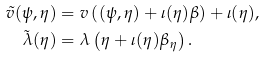Convert formula to latex. <formula><loc_0><loc_0><loc_500><loc_500>\tilde { v } ( \psi , \eta ) & = v \left ( ( \psi , \eta ) + \iota ( \eta ) \beta \right ) + \iota ( \eta ) , \\ \tilde { \lambda } ( \eta ) & = \lambda \left ( \eta + \iota ( \eta ) \beta _ { \eta } \right ) .</formula> 